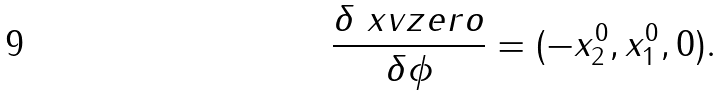Convert formula to latex. <formula><loc_0><loc_0><loc_500><loc_500>\frac { \delta \ x v z e r o } { \delta \phi } = ( - x ^ { 0 } _ { 2 } , x ^ { 0 } _ { 1 } , 0 ) .</formula> 